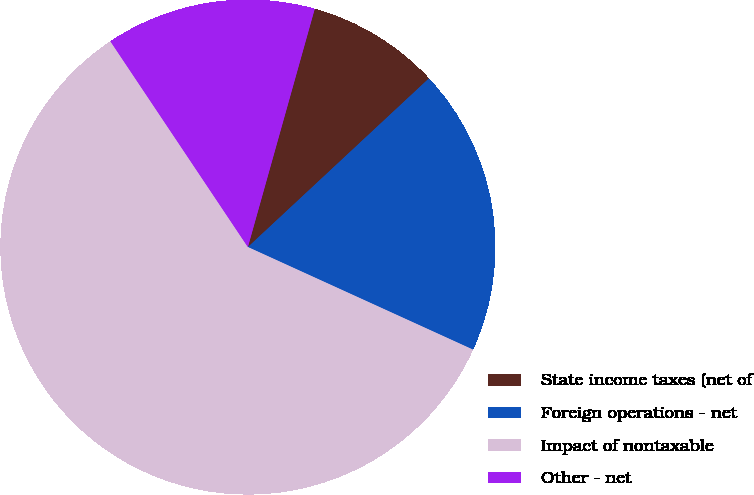Convert chart to OTSL. <chart><loc_0><loc_0><loc_500><loc_500><pie_chart><fcel>State income taxes (net of<fcel>Foreign operations - net<fcel>Impact of nontaxable<fcel>Other - net<nl><fcel>8.71%<fcel>18.74%<fcel>58.82%<fcel>13.73%<nl></chart> 